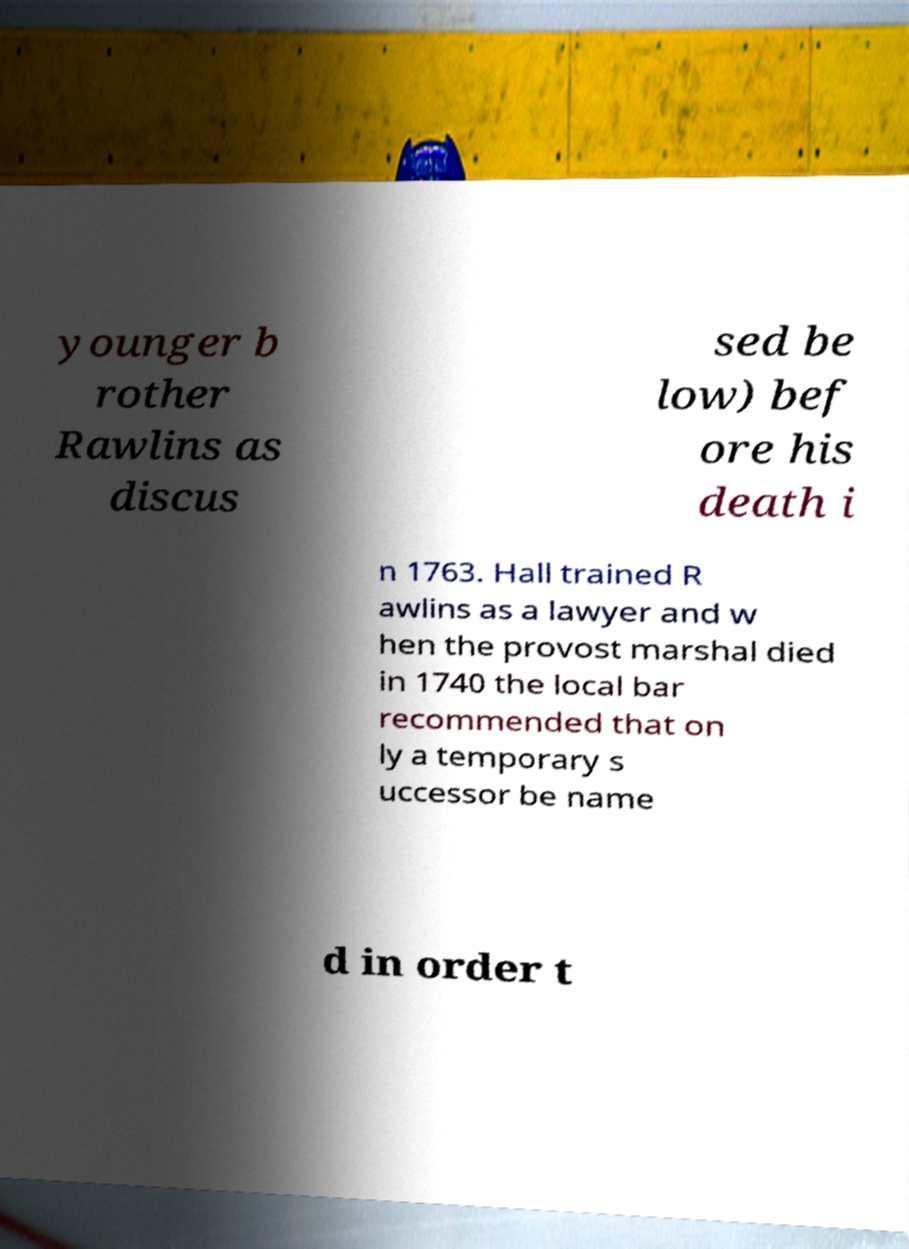Please identify and transcribe the text found in this image. younger b rother Rawlins as discus sed be low) bef ore his death i n 1763. Hall trained R awlins as a lawyer and w hen the provost marshal died in 1740 the local bar recommended that on ly a temporary s uccessor be name d in order t 